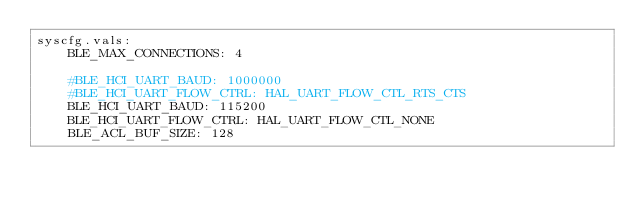Convert code to text. <code><loc_0><loc_0><loc_500><loc_500><_YAML_>syscfg.vals:
    BLE_MAX_CONNECTIONS: 4

    #BLE_HCI_UART_BAUD: 1000000
    #BLE_HCI_UART_FLOW_CTRL: HAL_UART_FLOW_CTL_RTS_CTS
    BLE_HCI_UART_BAUD: 115200
    BLE_HCI_UART_FLOW_CTRL: HAL_UART_FLOW_CTL_NONE
    BLE_ACL_BUF_SIZE: 128
</code> 